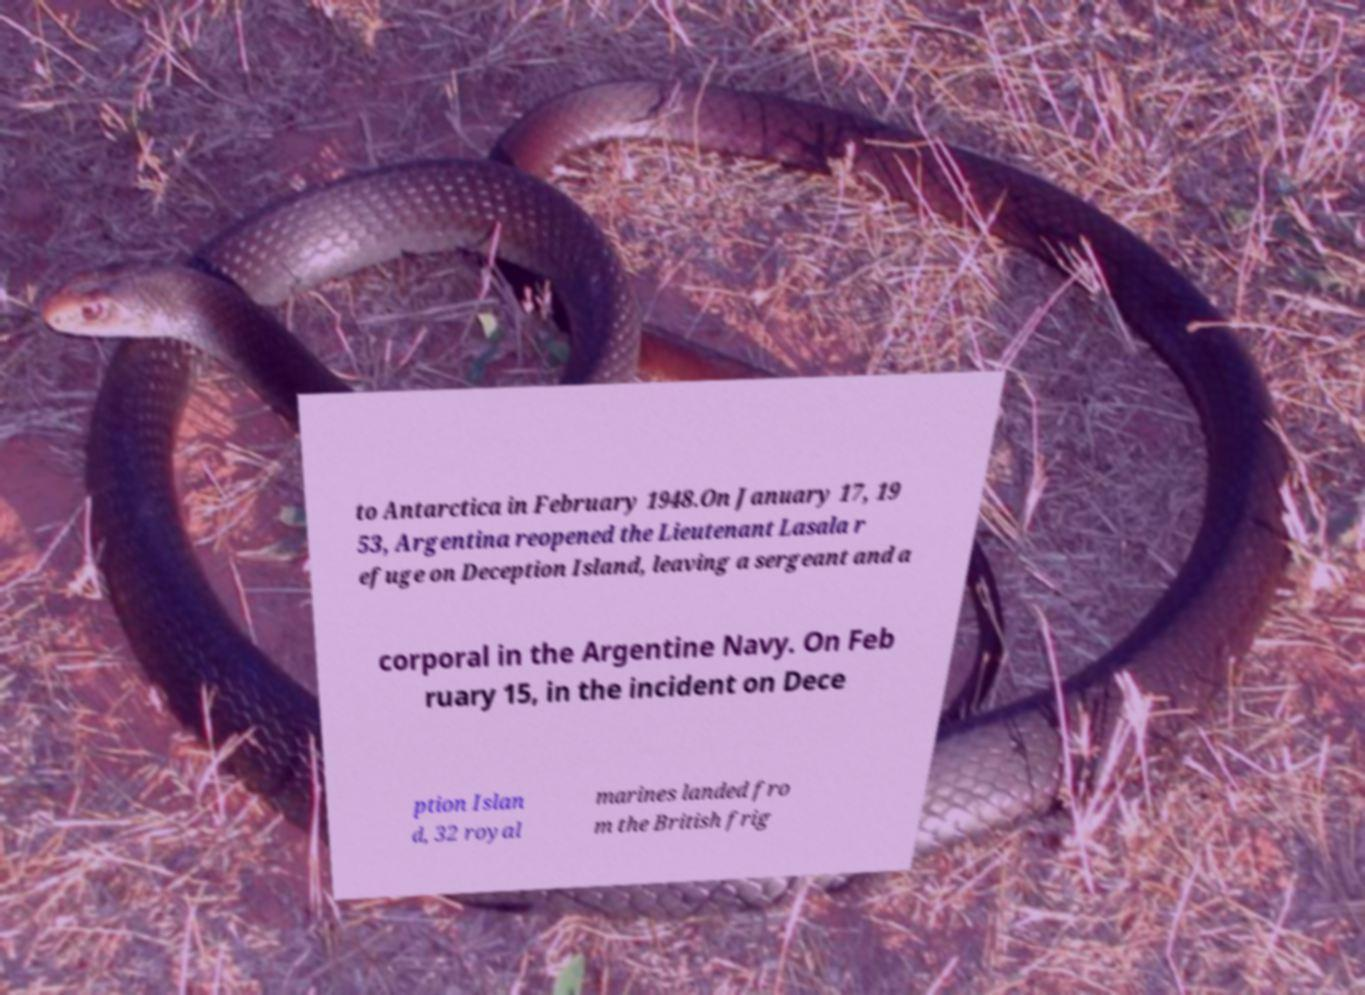I need the written content from this picture converted into text. Can you do that? to Antarctica in February 1948.On January 17, 19 53, Argentina reopened the Lieutenant Lasala r efuge on Deception Island, leaving a sergeant and a corporal in the Argentine Navy. On Feb ruary 15, in the incident on Dece ption Islan d, 32 royal marines landed fro m the British frig 